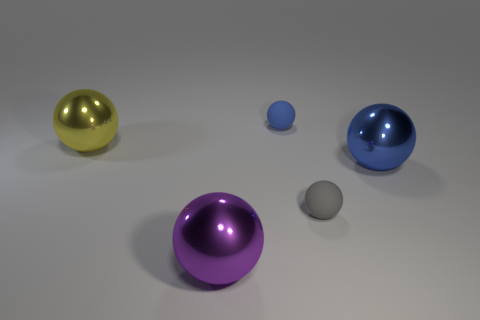Subtract all big blue metallic spheres. How many spheres are left? 4 Add 2 cyan spheres. How many objects exist? 7 Subtract 4 balls. How many balls are left? 1 Subtract all gray balls. How many balls are left? 4 Subtract all yellow cubes. How many purple spheres are left? 1 Add 2 blue things. How many blue things exist? 4 Subtract 0 gray cylinders. How many objects are left? 5 Subtract all blue balls. Subtract all red cylinders. How many balls are left? 3 Subtract all shiny things. Subtract all yellow metallic things. How many objects are left? 1 Add 4 large yellow metallic objects. How many large yellow metallic objects are left? 5 